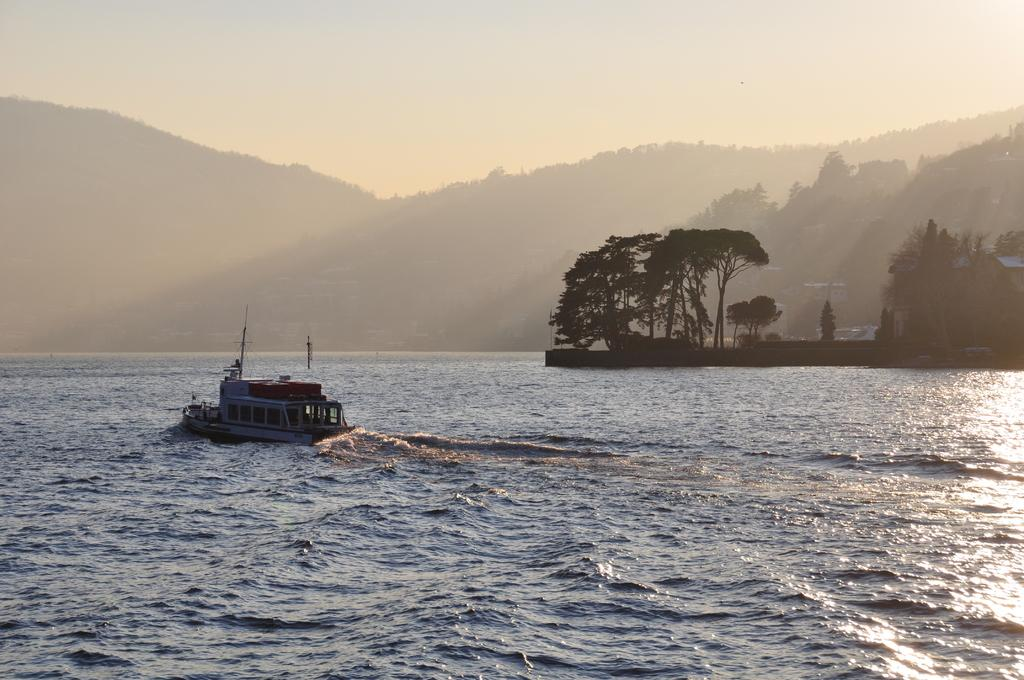What is the main feature of the landscape in the image? There is a body of water in the image. What is located in the water? There is a sailing boat in the water. What type of vegetation is near the water? There are trees near the water. What can be seen in the background of the image? There are mountains with trees in the background. What is visible at the top of the image? The sky is visible at the top of the image. What type of arm is visible in the image? There is no arm present in the image. What meal is being prepared on the boat in the image? There is no indication of a meal being prepared on the boat in the image. 